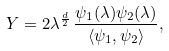Convert formula to latex. <formula><loc_0><loc_0><loc_500><loc_500>Y = 2 \lambda ^ { \frac { d } { 2 } } \, \frac { \psi _ { 1 } ( \lambda ) \psi _ { 2 } ( \lambda ) } { \langle \psi _ { 1 } , \psi _ { 2 } \rangle } ,</formula> 